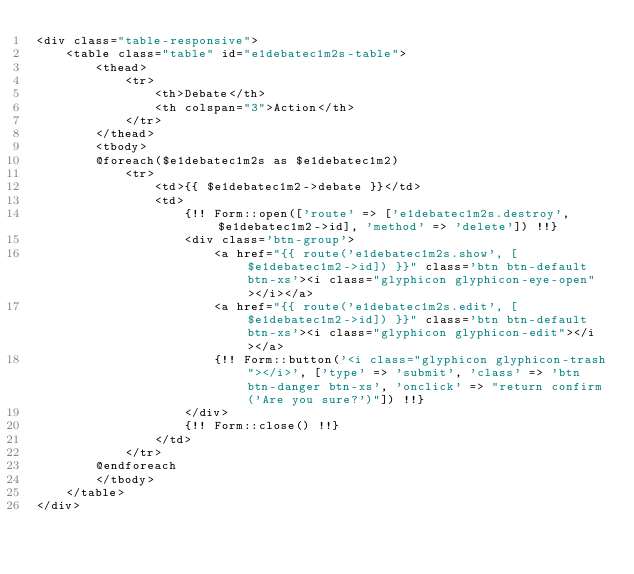Convert code to text. <code><loc_0><loc_0><loc_500><loc_500><_PHP_><div class="table-responsive">
    <table class="table" id="e1debatec1m2s-table">
        <thead>
            <tr>
                <th>Debate</th>
                <th colspan="3">Action</th>
            </tr>
        </thead>
        <tbody>
        @foreach($e1debatec1m2s as $e1debatec1m2)
            <tr>
                <td>{{ $e1debatec1m2->debate }}</td>
                <td>
                    {!! Form::open(['route' => ['e1debatec1m2s.destroy', $e1debatec1m2->id], 'method' => 'delete']) !!}
                    <div class='btn-group'>
                        <a href="{{ route('e1debatec1m2s.show', [$e1debatec1m2->id]) }}" class='btn btn-default btn-xs'><i class="glyphicon glyphicon-eye-open"></i></a>
                        <a href="{{ route('e1debatec1m2s.edit', [$e1debatec1m2->id]) }}" class='btn btn-default btn-xs'><i class="glyphicon glyphicon-edit"></i></a>
                        {!! Form::button('<i class="glyphicon glyphicon-trash"></i>', ['type' => 'submit', 'class' => 'btn btn-danger btn-xs', 'onclick' => "return confirm('Are you sure?')"]) !!}
                    </div>
                    {!! Form::close() !!}
                </td>
            </tr>
        @endforeach
        </tbody>
    </table>
</div>
</code> 